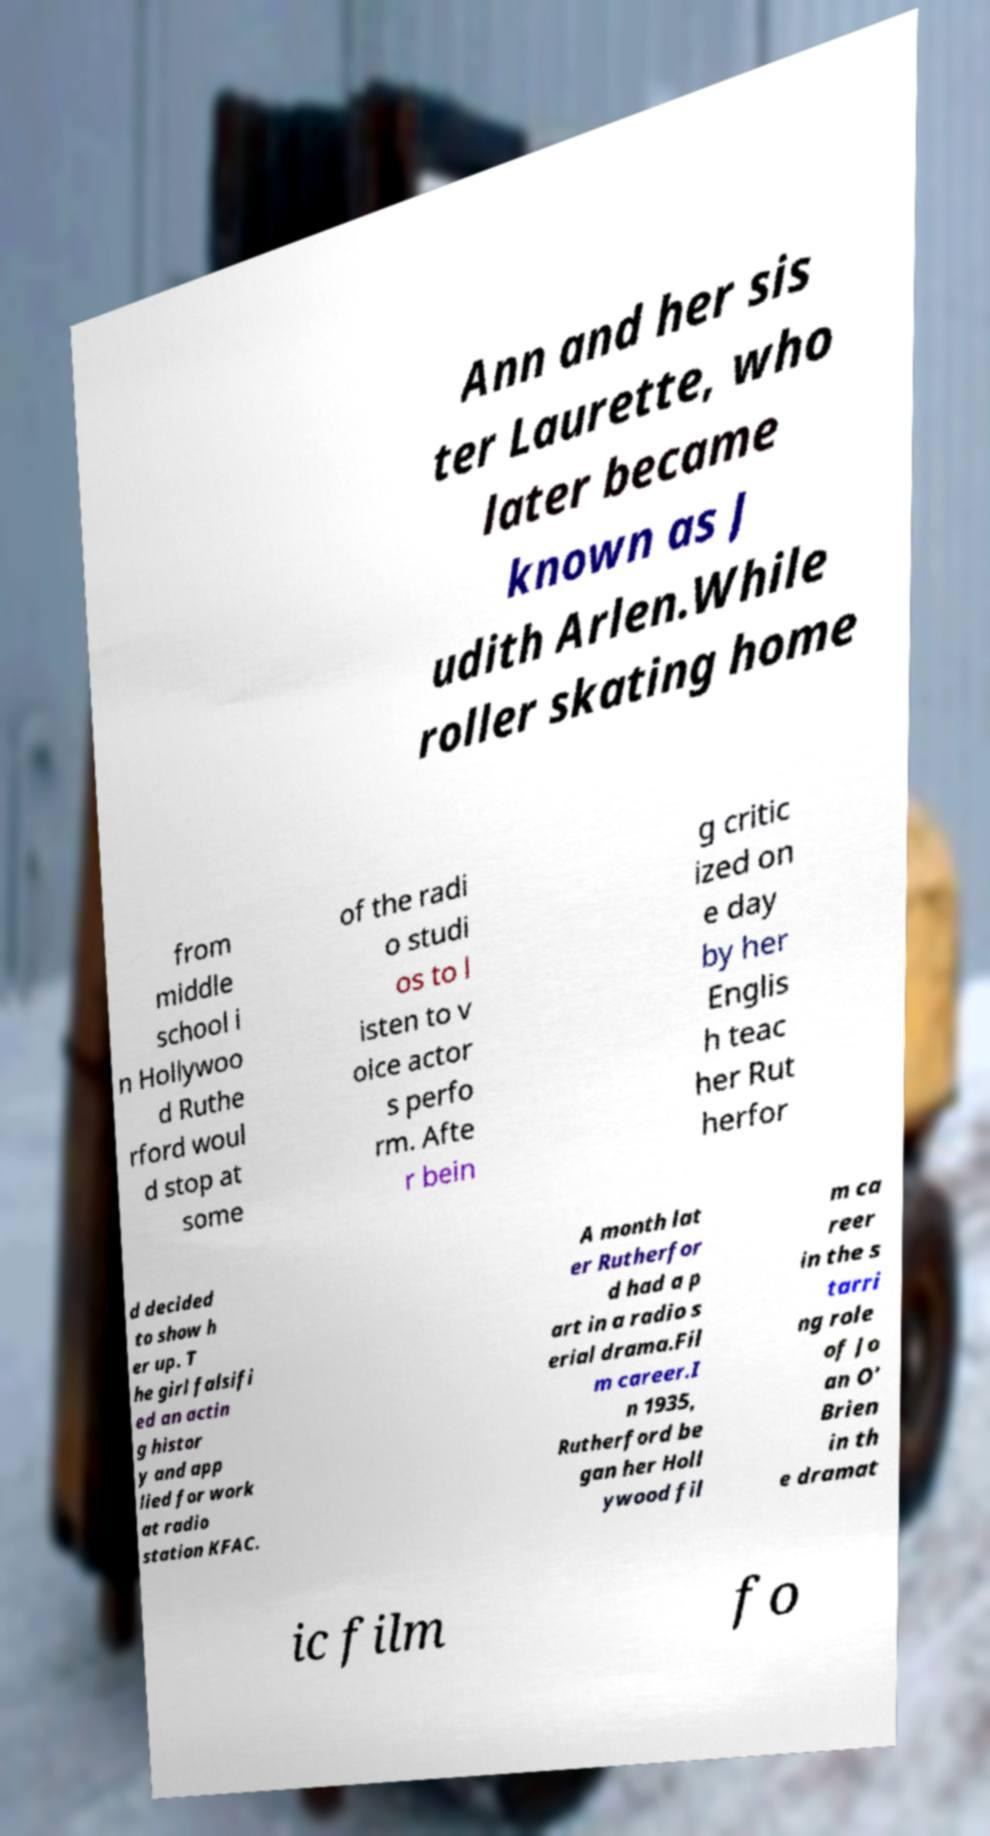Please read and relay the text visible in this image. What does it say? Ann and her sis ter Laurette, who later became known as J udith Arlen.While roller skating home from middle school i n Hollywoo d Ruthe rford woul d stop at some of the radi o studi os to l isten to v oice actor s perfo rm. Afte r bein g critic ized on e day by her Englis h teac her Rut herfor d decided to show h er up. T he girl falsifi ed an actin g histor y and app lied for work at radio station KFAC. A month lat er Rutherfor d had a p art in a radio s erial drama.Fil m career.I n 1935, Rutherford be gan her Holl ywood fil m ca reer in the s tarri ng role of Jo an O' Brien in th e dramat ic film fo 